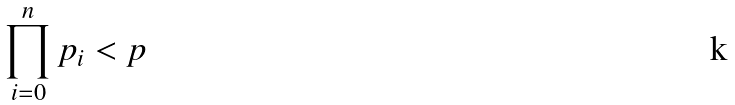<formula> <loc_0><loc_0><loc_500><loc_500>\prod _ { i = 0 } ^ { n } p _ { i } < p</formula> 